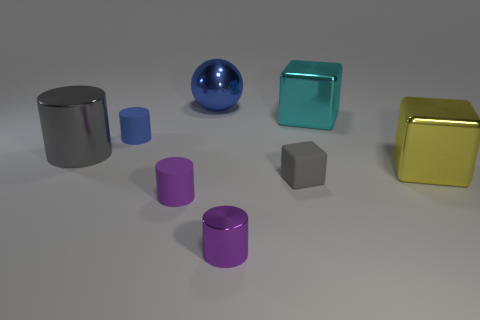Subtract all gray cubes. How many cubes are left? 2 Add 2 big gray rubber balls. How many objects exist? 10 Subtract 1 cubes. How many cubes are left? 2 Subtract all purple cylinders. How many cylinders are left? 2 Subtract all blocks. How many objects are left? 5 Subtract 0 brown cylinders. How many objects are left? 8 Subtract all brown cubes. Subtract all blue cylinders. How many cubes are left? 3 Subtract all brown cubes. How many purple cylinders are left? 2 Subtract all purple objects. Subtract all big metallic spheres. How many objects are left? 5 Add 1 blue spheres. How many blue spheres are left? 2 